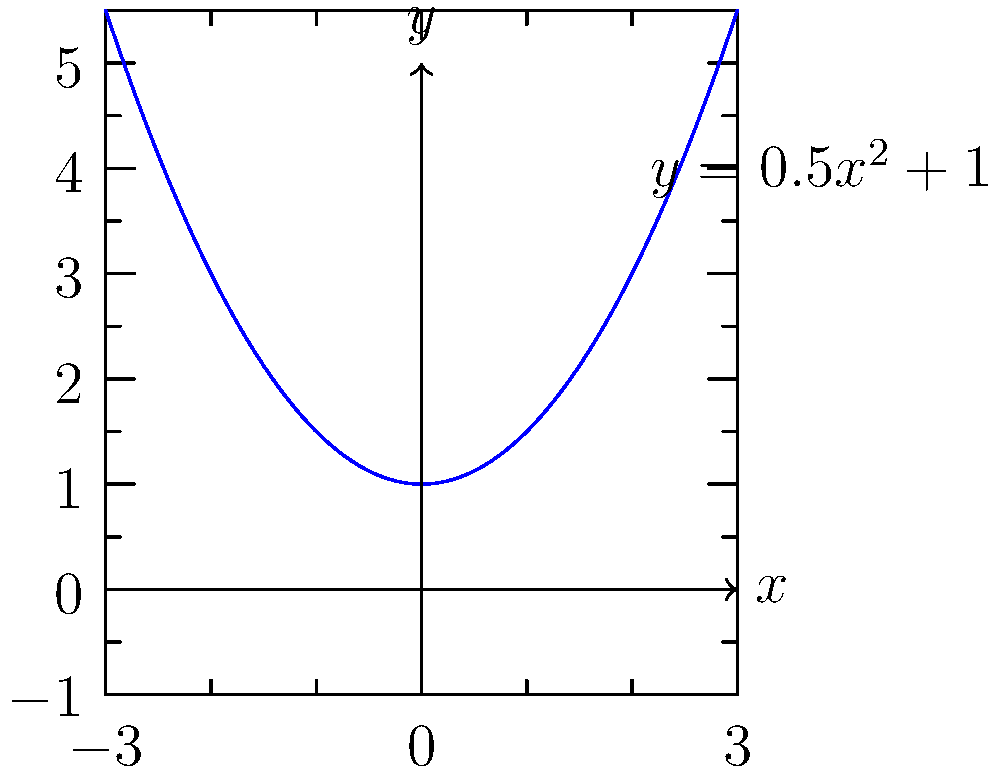The graph shows the methane production rate $y$ (in m³/day) as a function of substrate concentration $x$ (in g/L) for an anaerobic digester. If this graph is reflected across the y-axis, what would be the new equation representing the methane production rate? To reflect a graph across the y-axis, we need to change the sign of all x-terms in the equation while keeping the y-terms and constants the same. Let's approach this step-by-step:

1. The original equation is $y = 0.5x^2 + 1$

2. In this equation, we have an $x^2$ term. When we reflect across the y-axis, $x$ becomes $-x$, but $(-x)^2 = x^2$, so this term doesn't change.

3. There are no linear $x$ terms in this equation, but if there were, their signs would change.

4. The constant term (1 in this case) remains unchanged.

5. Therefore, after reflection across the y-axis, the equation remains $y = 0.5x^2 + 1$

This makes sense because a parabola that opens upward and has its vertex on the y-axis is symmetrical about the y-axis, so reflecting it doesn't change its equation.
Answer: $y = 0.5x^2 + 1$ 